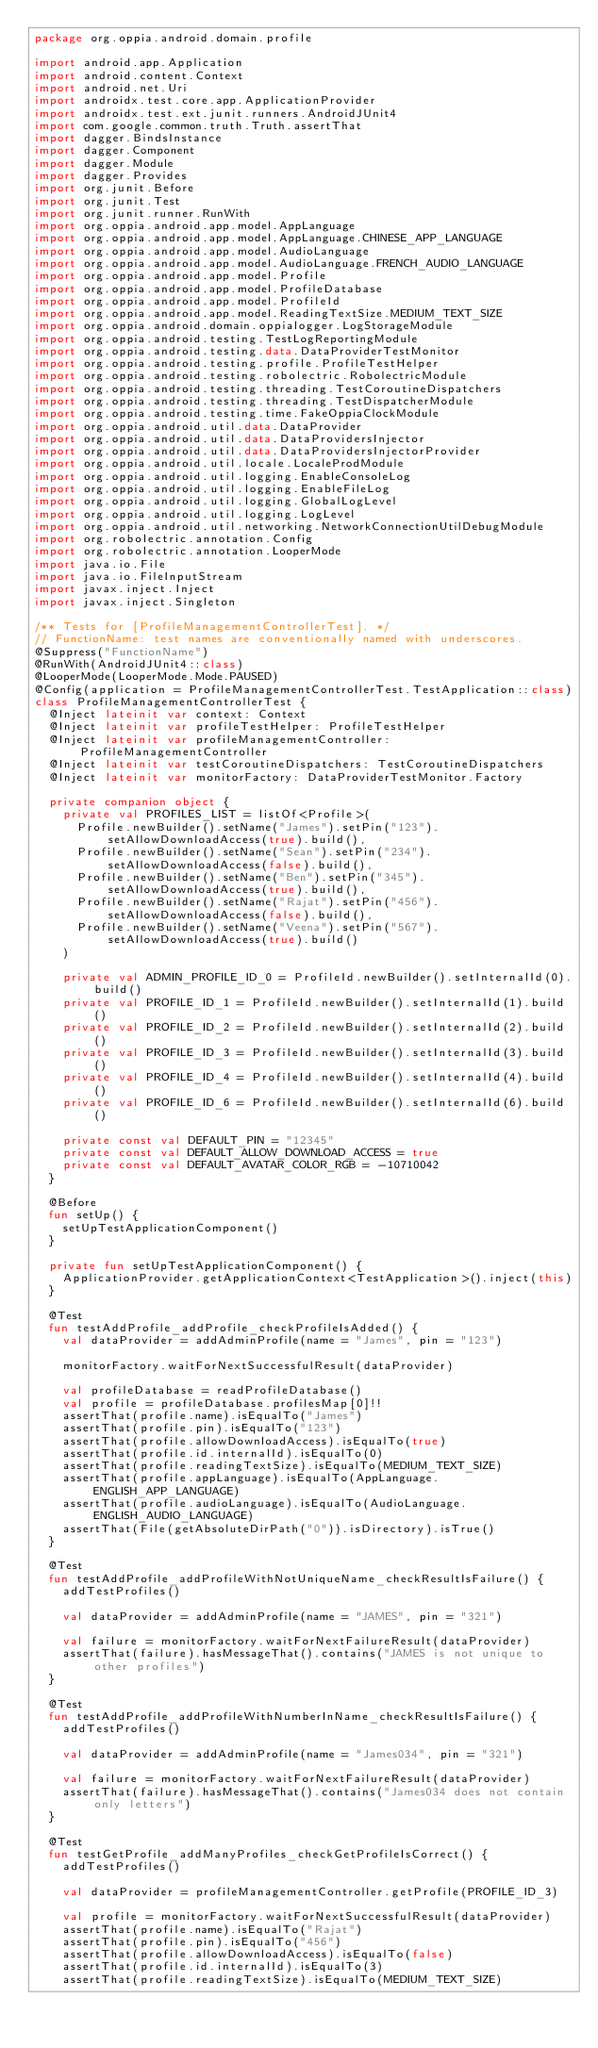Convert code to text. <code><loc_0><loc_0><loc_500><loc_500><_Kotlin_>package org.oppia.android.domain.profile

import android.app.Application
import android.content.Context
import android.net.Uri
import androidx.test.core.app.ApplicationProvider
import androidx.test.ext.junit.runners.AndroidJUnit4
import com.google.common.truth.Truth.assertThat
import dagger.BindsInstance
import dagger.Component
import dagger.Module
import dagger.Provides
import org.junit.Before
import org.junit.Test
import org.junit.runner.RunWith
import org.oppia.android.app.model.AppLanguage
import org.oppia.android.app.model.AppLanguage.CHINESE_APP_LANGUAGE
import org.oppia.android.app.model.AudioLanguage
import org.oppia.android.app.model.AudioLanguage.FRENCH_AUDIO_LANGUAGE
import org.oppia.android.app.model.Profile
import org.oppia.android.app.model.ProfileDatabase
import org.oppia.android.app.model.ProfileId
import org.oppia.android.app.model.ReadingTextSize.MEDIUM_TEXT_SIZE
import org.oppia.android.domain.oppialogger.LogStorageModule
import org.oppia.android.testing.TestLogReportingModule
import org.oppia.android.testing.data.DataProviderTestMonitor
import org.oppia.android.testing.profile.ProfileTestHelper
import org.oppia.android.testing.robolectric.RobolectricModule
import org.oppia.android.testing.threading.TestCoroutineDispatchers
import org.oppia.android.testing.threading.TestDispatcherModule
import org.oppia.android.testing.time.FakeOppiaClockModule
import org.oppia.android.util.data.DataProvider
import org.oppia.android.util.data.DataProvidersInjector
import org.oppia.android.util.data.DataProvidersInjectorProvider
import org.oppia.android.util.locale.LocaleProdModule
import org.oppia.android.util.logging.EnableConsoleLog
import org.oppia.android.util.logging.EnableFileLog
import org.oppia.android.util.logging.GlobalLogLevel
import org.oppia.android.util.logging.LogLevel
import org.oppia.android.util.networking.NetworkConnectionUtilDebugModule
import org.robolectric.annotation.Config
import org.robolectric.annotation.LooperMode
import java.io.File
import java.io.FileInputStream
import javax.inject.Inject
import javax.inject.Singleton

/** Tests for [ProfileManagementControllerTest]. */
// FunctionName: test names are conventionally named with underscores.
@Suppress("FunctionName")
@RunWith(AndroidJUnit4::class)
@LooperMode(LooperMode.Mode.PAUSED)
@Config(application = ProfileManagementControllerTest.TestApplication::class)
class ProfileManagementControllerTest {
  @Inject lateinit var context: Context
  @Inject lateinit var profileTestHelper: ProfileTestHelper
  @Inject lateinit var profileManagementController: ProfileManagementController
  @Inject lateinit var testCoroutineDispatchers: TestCoroutineDispatchers
  @Inject lateinit var monitorFactory: DataProviderTestMonitor.Factory

  private companion object {
    private val PROFILES_LIST = listOf<Profile>(
      Profile.newBuilder().setName("James").setPin("123").setAllowDownloadAccess(true).build(),
      Profile.newBuilder().setName("Sean").setPin("234").setAllowDownloadAccess(false).build(),
      Profile.newBuilder().setName("Ben").setPin("345").setAllowDownloadAccess(true).build(),
      Profile.newBuilder().setName("Rajat").setPin("456").setAllowDownloadAccess(false).build(),
      Profile.newBuilder().setName("Veena").setPin("567").setAllowDownloadAccess(true).build()
    )

    private val ADMIN_PROFILE_ID_0 = ProfileId.newBuilder().setInternalId(0).build()
    private val PROFILE_ID_1 = ProfileId.newBuilder().setInternalId(1).build()
    private val PROFILE_ID_2 = ProfileId.newBuilder().setInternalId(2).build()
    private val PROFILE_ID_3 = ProfileId.newBuilder().setInternalId(3).build()
    private val PROFILE_ID_4 = ProfileId.newBuilder().setInternalId(4).build()
    private val PROFILE_ID_6 = ProfileId.newBuilder().setInternalId(6).build()

    private const val DEFAULT_PIN = "12345"
    private const val DEFAULT_ALLOW_DOWNLOAD_ACCESS = true
    private const val DEFAULT_AVATAR_COLOR_RGB = -10710042
  }

  @Before
  fun setUp() {
    setUpTestApplicationComponent()
  }

  private fun setUpTestApplicationComponent() {
    ApplicationProvider.getApplicationContext<TestApplication>().inject(this)
  }

  @Test
  fun testAddProfile_addProfile_checkProfileIsAdded() {
    val dataProvider = addAdminProfile(name = "James", pin = "123")

    monitorFactory.waitForNextSuccessfulResult(dataProvider)

    val profileDatabase = readProfileDatabase()
    val profile = profileDatabase.profilesMap[0]!!
    assertThat(profile.name).isEqualTo("James")
    assertThat(profile.pin).isEqualTo("123")
    assertThat(profile.allowDownloadAccess).isEqualTo(true)
    assertThat(profile.id.internalId).isEqualTo(0)
    assertThat(profile.readingTextSize).isEqualTo(MEDIUM_TEXT_SIZE)
    assertThat(profile.appLanguage).isEqualTo(AppLanguage.ENGLISH_APP_LANGUAGE)
    assertThat(profile.audioLanguage).isEqualTo(AudioLanguage.ENGLISH_AUDIO_LANGUAGE)
    assertThat(File(getAbsoluteDirPath("0")).isDirectory).isTrue()
  }

  @Test
  fun testAddProfile_addProfileWithNotUniqueName_checkResultIsFailure() {
    addTestProfiles()

    val dataProvider = addAdminProfile(name = "JAMES", pin = "321")

    val failure = monitorFactory.waitForNextFailureResult(dataProvider)
    assertThat(failure).hasMessageThat().contains("JAMES is not unique to other profiles")
  }

  @Test
  fun testAddProfile_addProfileWithNumberInName_checkResultIsFailure() {
    addTestProfiles()

    val dataProvider = addAdminProfile(name = "James034", pin = "321")

    val failure = monitorFactory.waitForNextFailureResult(dataProvider)
    assertThat(failure).hasMessageThat().contains("James034 does not contain only letters")
  }

  @Test
  fun testGetProfile_addManyProfiles_checkGetProfileIsCorrect() {
    addTestProfiles()

    val dataProvider = profileManagementController.getProfile(PROFILE_ID_3)

    val profile = monitorFactory.waitForNextSuccessfulResult(dataProvider)
    assertThat(profile.name).isEqualTo("Rajat")
    assertThat(profile.pin).isEqualTo("456")
    assertThat(profile.allowDownloadAccess).isEqualTo(false)
    assertThat(profile.id.internalId).isEqualTo(3)
    assertThat(profile.readingTextSize).isEqualTo(MEDIUM_TEXT_SIZE)</code> 